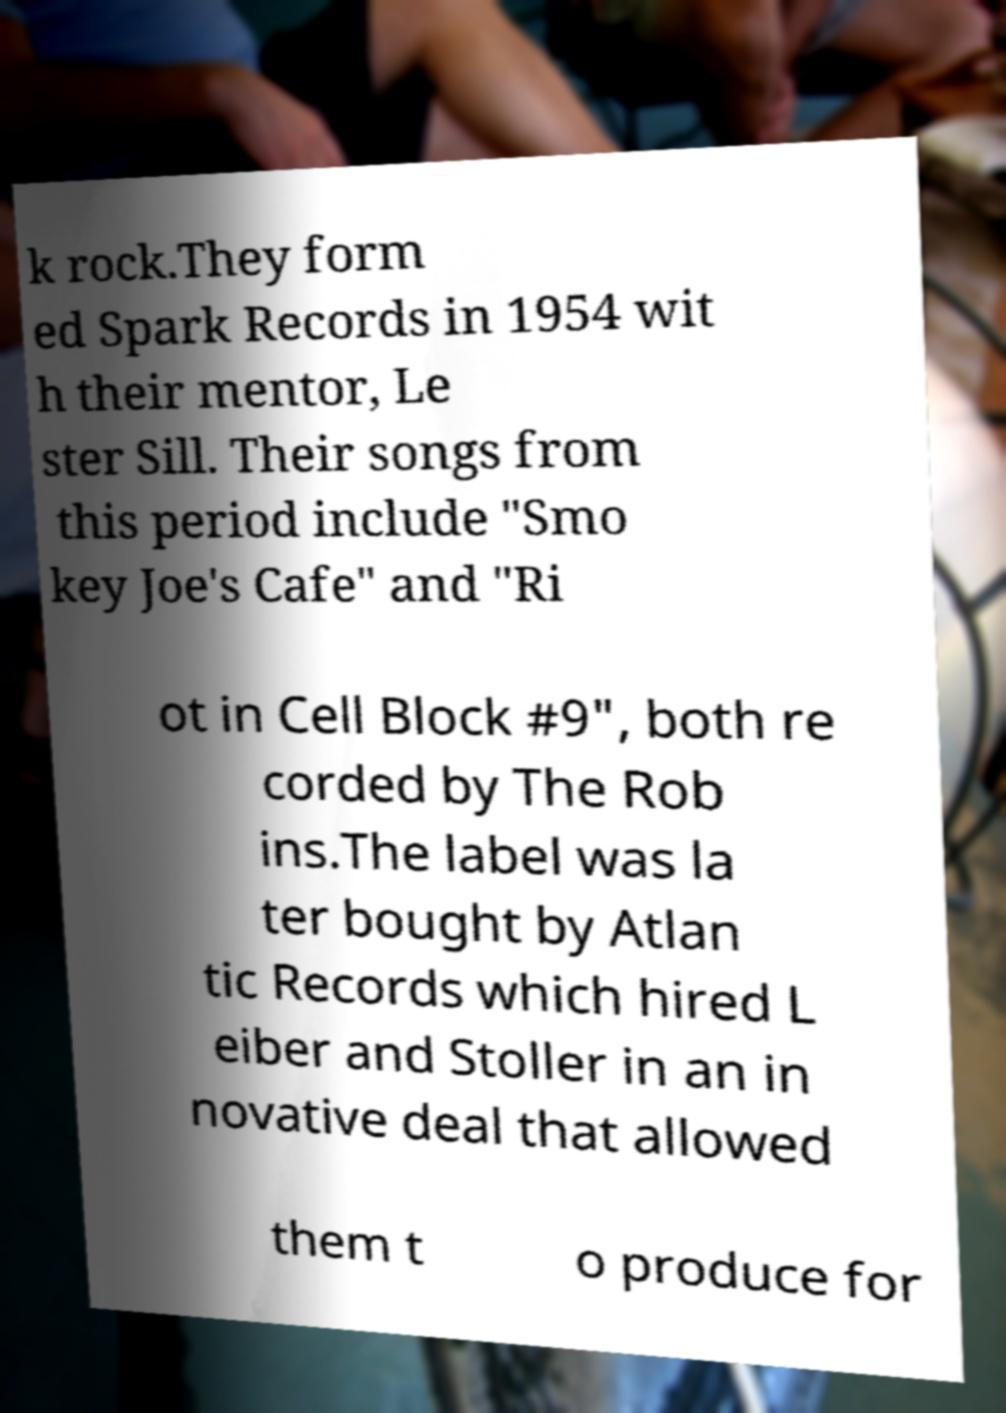Please read and relay the text visible in this image. What does it say? k rock.They form ed Spark Records in 1954 wit h their mentor, Le ster Sill. Their songs from this period include "Smo key Joe's Cafe" and "Ri ot in Cell Block #9", both re corded by The Rob ins.The label was la ter bought by Atlan tic Records which hired L eiber and Stoller in an in novative deal that allowed them t o produce for 